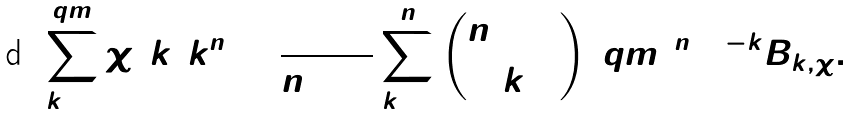Convert formula to latex. <formula><loc_0><loc_0><loc_500><loc_500>\sum ^ { q m } _ { k = 1 } \chi ( k ) k ^ { n } = \frac { 1 } { n + 1 } \sum ^ { n } _ { k = 0 } { n + 1 \choose { k } } ( q m ) ^ { n + 1 - k } B _ { k , \chi } .</formula> 